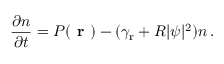<formula> <loc_0><loc_0><loc_500><loc_500>\frac { \partial { n } } { \partial { t } } = P ( r ) - ( \gamma _ { r } + R | \psi | ^ { 2 } ) n \, .</formula> 